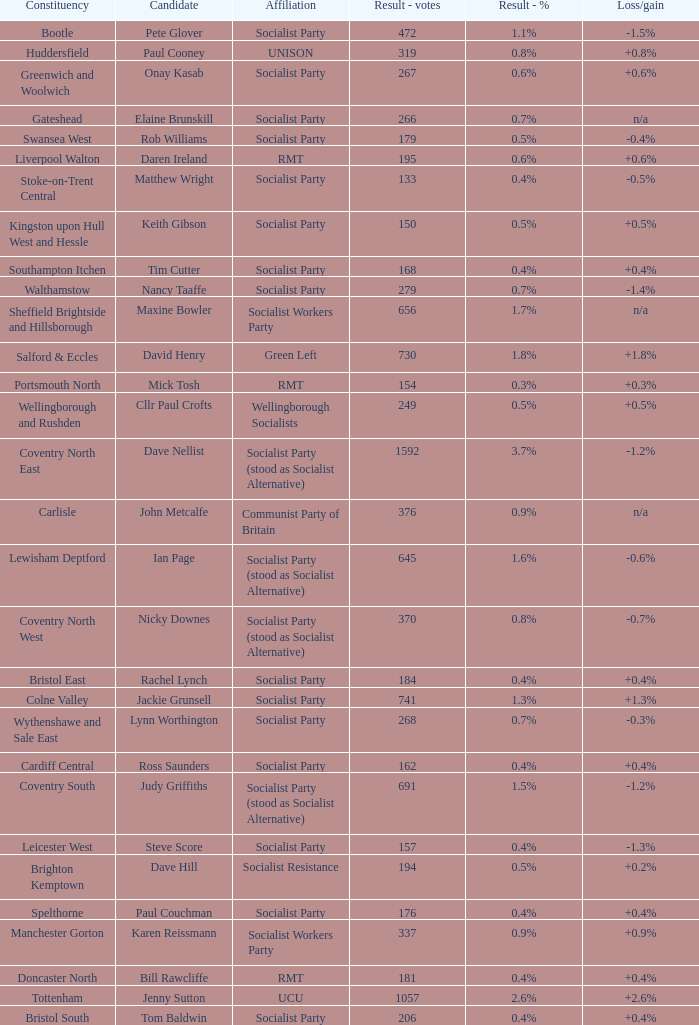How many values for constituency for the vote result of 162? 1.0. 